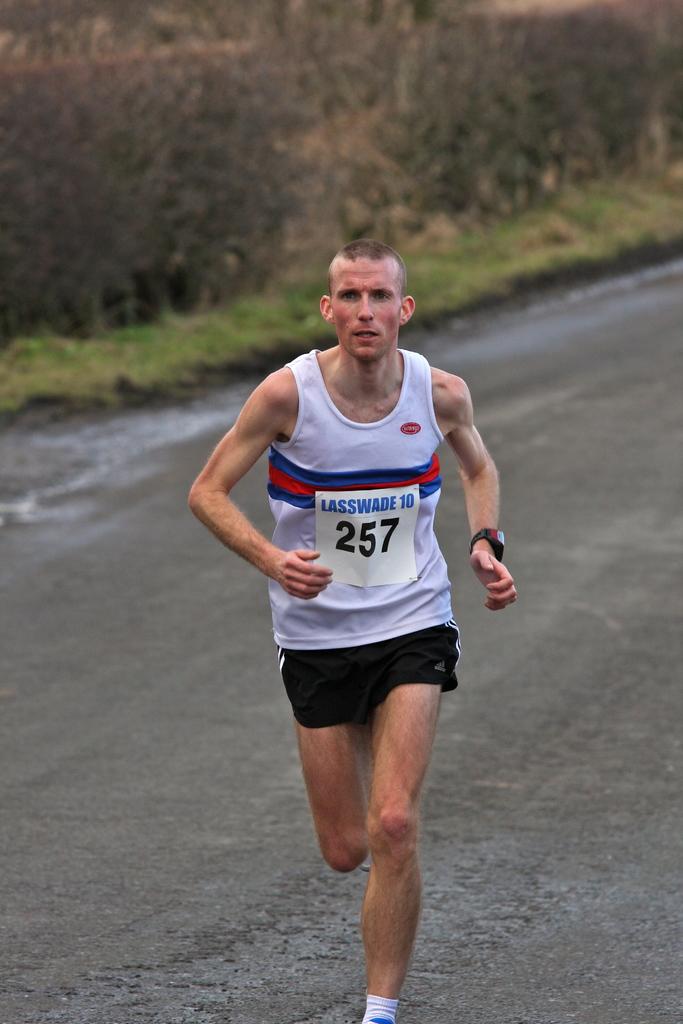What is this runner's number?
Keep it short and to the point. 257. What colors are the stripes on his shirt?
Offer a terse response. Red and blue. 